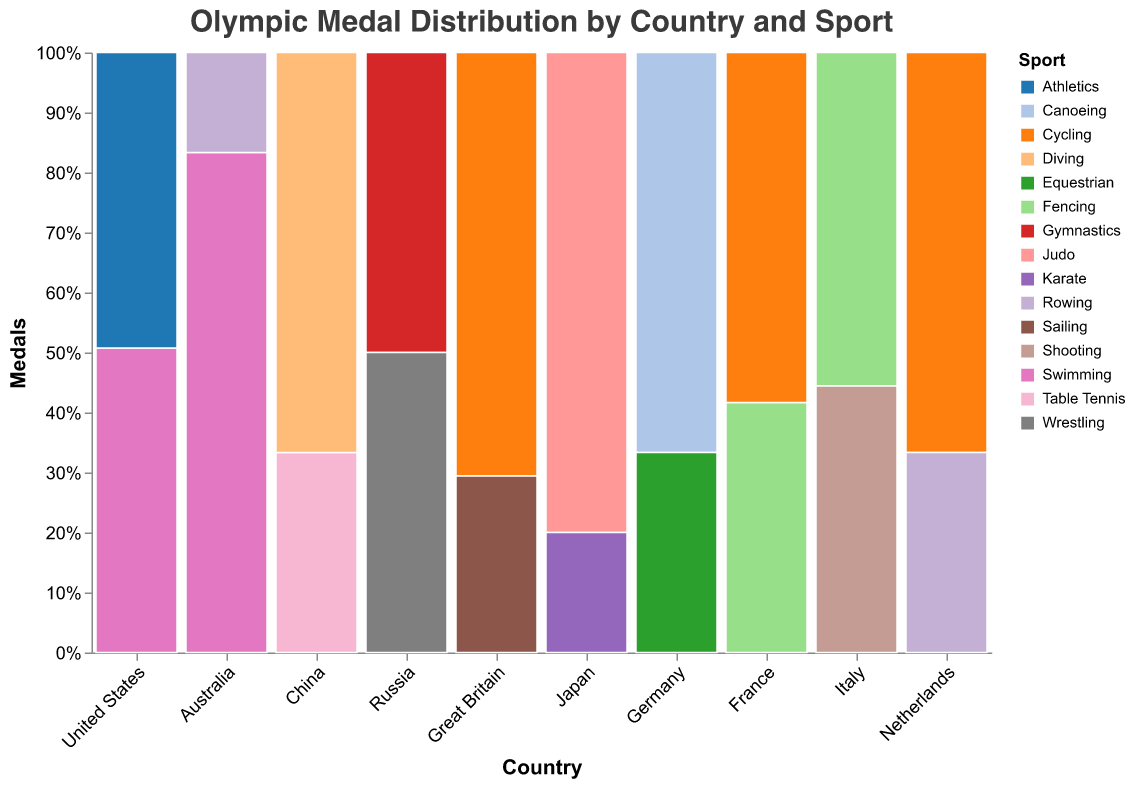What is the total number of medals won by the United States in Swimming? The United States has a bar labeled "Swimming" with a value indicating the number of medals. From the figure, we see this value is 33.
Answer: 33 Which sport did China win the most medals in? Looking at the bars for China, we see that Diving has more medals than Table Tennis. Therefore, China won the most medals in Diving.
Answer: Diving How many more medals did the United States win in Athletics compared to any sport from Italy? The United States won 32 medals in Athletics. The sports represented for Italy are Shooting (4) and Fencing (5). Comparing these, the largest number of medals Italy won in a sport is 5. Thus, 32 - 5 = 27 more medals in Athletics.
Answer: 27 What percentage of Germany's total medals were won in Canoeing? Germany's Canoeing bar represents 10 medals. The total medals for Germany are Canoeing (10) + Equestrian (5) = 15. The percentage is (10/15) * 100% = 66.67%.
Answer: 66.67% Which sport contributed the least to Japan's medal count? For Japan, Judo has 12 medals, and Karate has 3. Karate is the sport with the least number of medals.
Answer: Karate How many countries won medals in Swimming? By scanning the bars labeled "Swimming," we see that the United States and Australia both have medals in Swimming. Hence, 2 countries have won medals in Swimming.
Answer: 2 Which country has the most diversified sports in terms of medal distribution? This can be determined by counting the unique sports each country won medals in. The United States has medals in 2 sports (Swimming and Athletics), China in 2 (Table Tennis and Diving), Russia in 2 (Gymnastics and Wrestling), and so on. Multiple countries have 2 unique sports each, but in terms of most diversified, this question would have a tie among them. Adjusting for visualization, the U.S. might appear more prominent due to higher medal counts in each sport, but for diversification, answer is tied.
Answer: United States, China, Russia, Japan, Germany, France, Great Britain (tie) What is the combined total number of medals won by Australia in both Swimming and Rowing? Summing the medals won in Swimming (20) and Rowing (4) for Australia, we get 20 + 4 = 24.
Answer: 24 Is the number of medals won by Japan in Judo more than the combined number of medals Russia won in Gymnastics and Wrestling? Japan won 12 medals in Judo. Russia won 9 in Gymnastics and 9 in Wrestling, which sums to 18. Comparing these, 12 is less than 18.
Answer: No Which country has a relatively balanced distribution of medals across different sports? Looking at the bars' heights per country, Russia shows a near-equal number of medals in two sports (9 in Gymnastics and 9 in Wrestling). This indicates a balanced distribution across sports for Russia.
Answer: Russia 